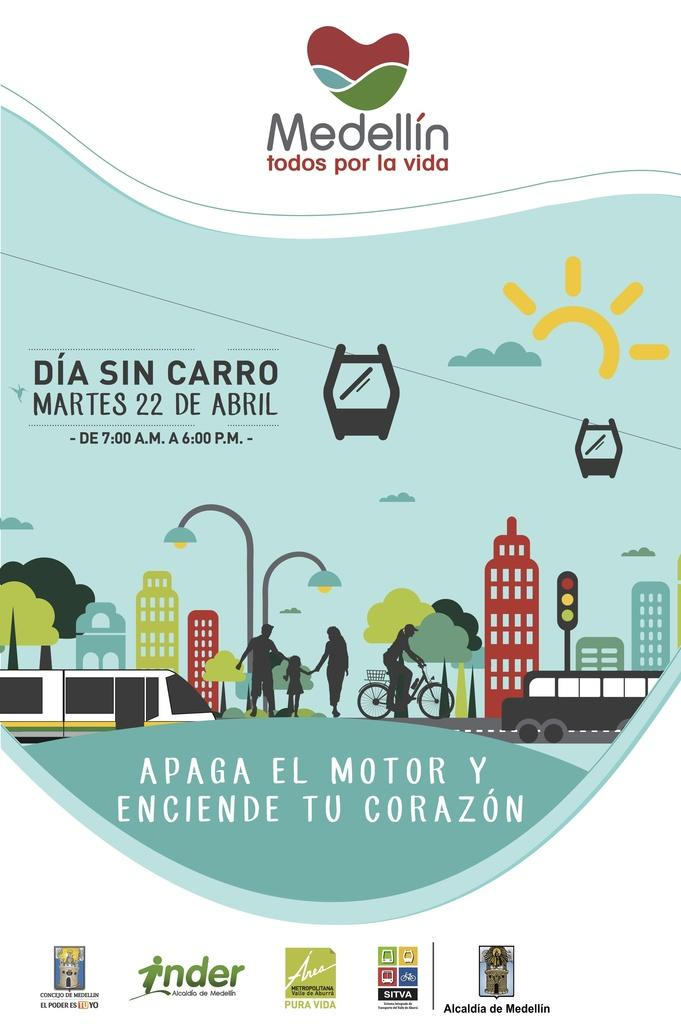<image>
Present a compact description of the photo's key features. A poster advertsises an event that will take place between the hours of 7:00 AM and 6:00 PM. 